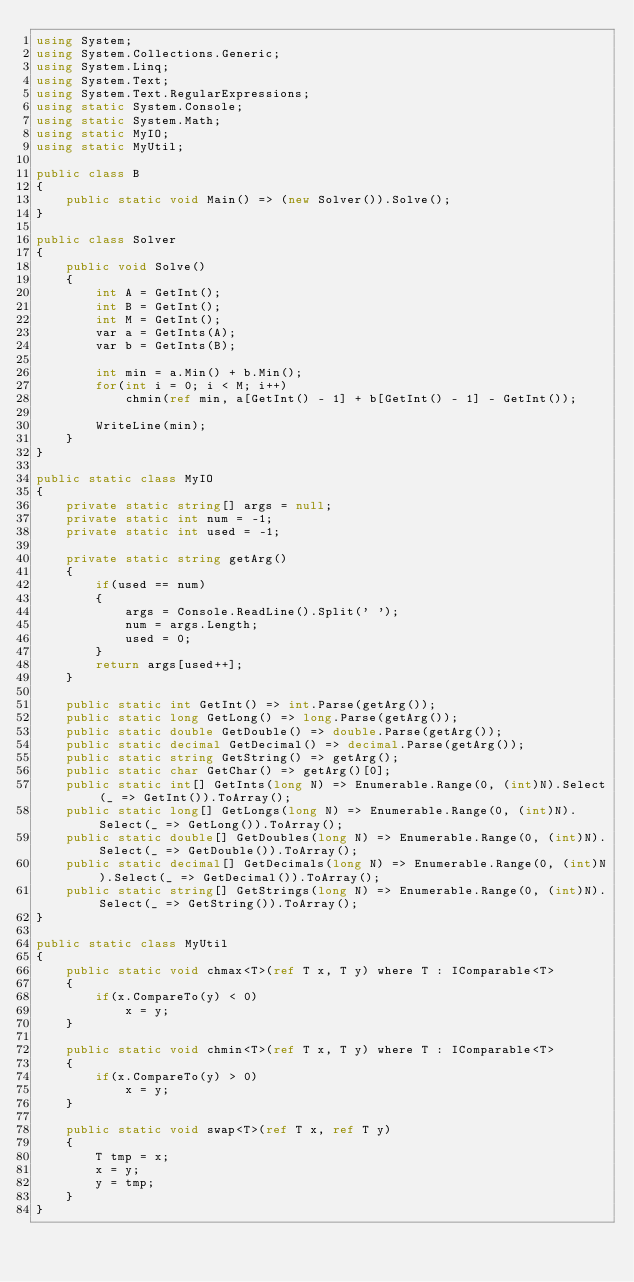<code> <loc_0><loc_0><loc_500><loc_500><_C#_>using System;
using System.Collections.Generic;
using System.Linq;
using System.Text;
using System.Text.RegularExpressions;
using static System.Console;
using static System.Math;
using static MyIO;
using static MyUtil;

public class B
{
	public static void Main() => (new Solver()).Solve();
}

public class Solver
{
	public void Solve()
	{
		int A = GetInt();
		int B = GetInt();
		int M = GetInt();
		var a = GetInts(A);
		var b = GetInts(B);

		int min = a.Min() + b.Min();
		for(int i = 0; i < M; i++)
			chmin(ref min, a[GetInt() - 1] + b[GetInt() - 1] - GetInt());

		WriteLine(min);
	}
}

public static class MyIO
{
	private static string[] args = null;
	private static int num = -1;
	private static int used = -1;

	private static string getArg()
	{
		if(used == num)
		{
			args = Console.ReadLine().Split(' ');
			num = args.Length;
			used = 0;
		}
		return args[used++];
	}

	public static int GetInt() => int.Parse(getArg());
	public static long GetLong() => long.Parse(getArg());
	public static double GetDouble() => double.Parse(getArg());
	public static decimal GetDecimal() => decimal.Parse(getArg());
	public static string GetString() => getArg();
	public static char GetChar() => getArg()[0];
	public static int[] GetInts(long N) => Enumerable.Range(0, (int)N).Select(_ => GetInt()).ToArray();
	public static long[] GetLongs(long N) => Enumerable.Range(0, (int)N).Select(_ => GetLong()).ToArray();
	public static double[] GetDoubles(long N) => Enumerable.Range(0, (int)N).Select(_ => GetDouble()).ToArray();
	public static decimal[] GetDecimals(long N) => Enumerable.Range(0, (int)N).Select(_ => GetDecimal()).ToArray();
	public static string[] GetStrings(long N) => Enumerable.Range(0, (int)N).Select(_ => GetString()).ToArray();
}

public static class MyUtil
{
	public static void chmax<T>(ref T x, T y) where T : IComparable<T>
	{
		if(x.CompareTo(y) < 0)
			x = y;
	}

	public static void chmin<T>(ref T x, T y) where T : IComparable<T>
	{
		if(x.CompareTo(y) > 0)
			x = y;
	}

	public static void swap<T>(ref T x, ref T y)
	{
		T tmp = x;
		x = y;
		y = tmp;
	}
}</code> 